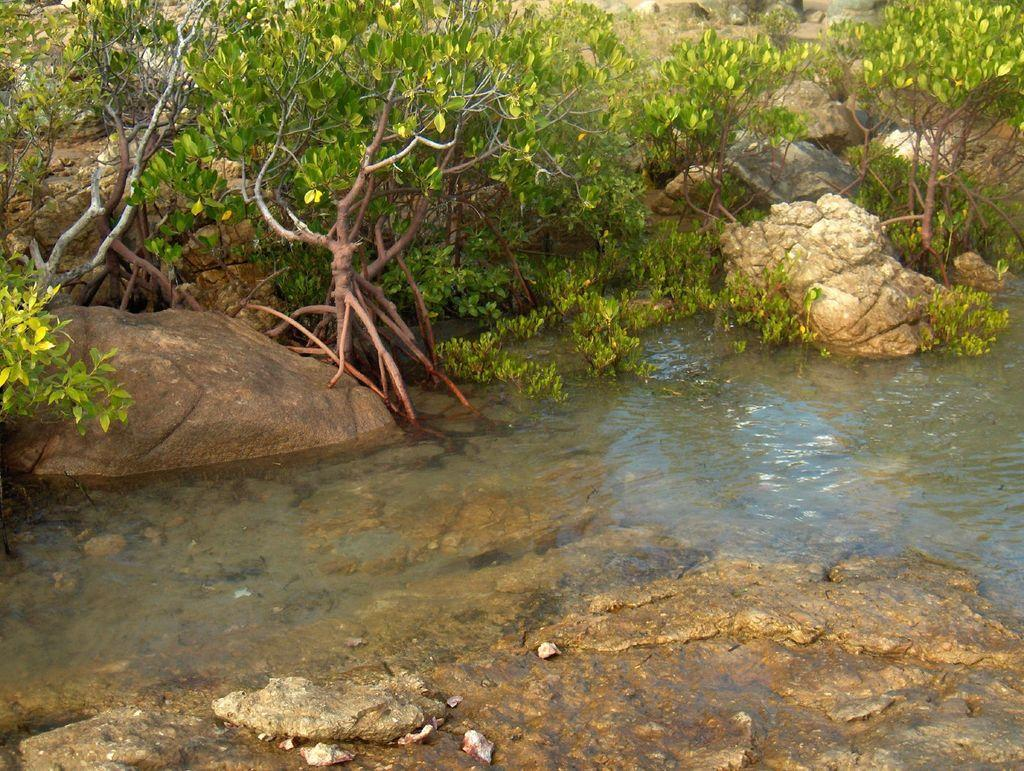What type of natural features can be seen in the image? There are rocks, trees, and mountains in the image. Can you describe the landscape in the image? The image may depict a landscape with rocks, trees, and mountains, possibly near a lake. What time does the queen appear in the image? There is no queen present in the image, so it is not possible to determine when she might appear. 